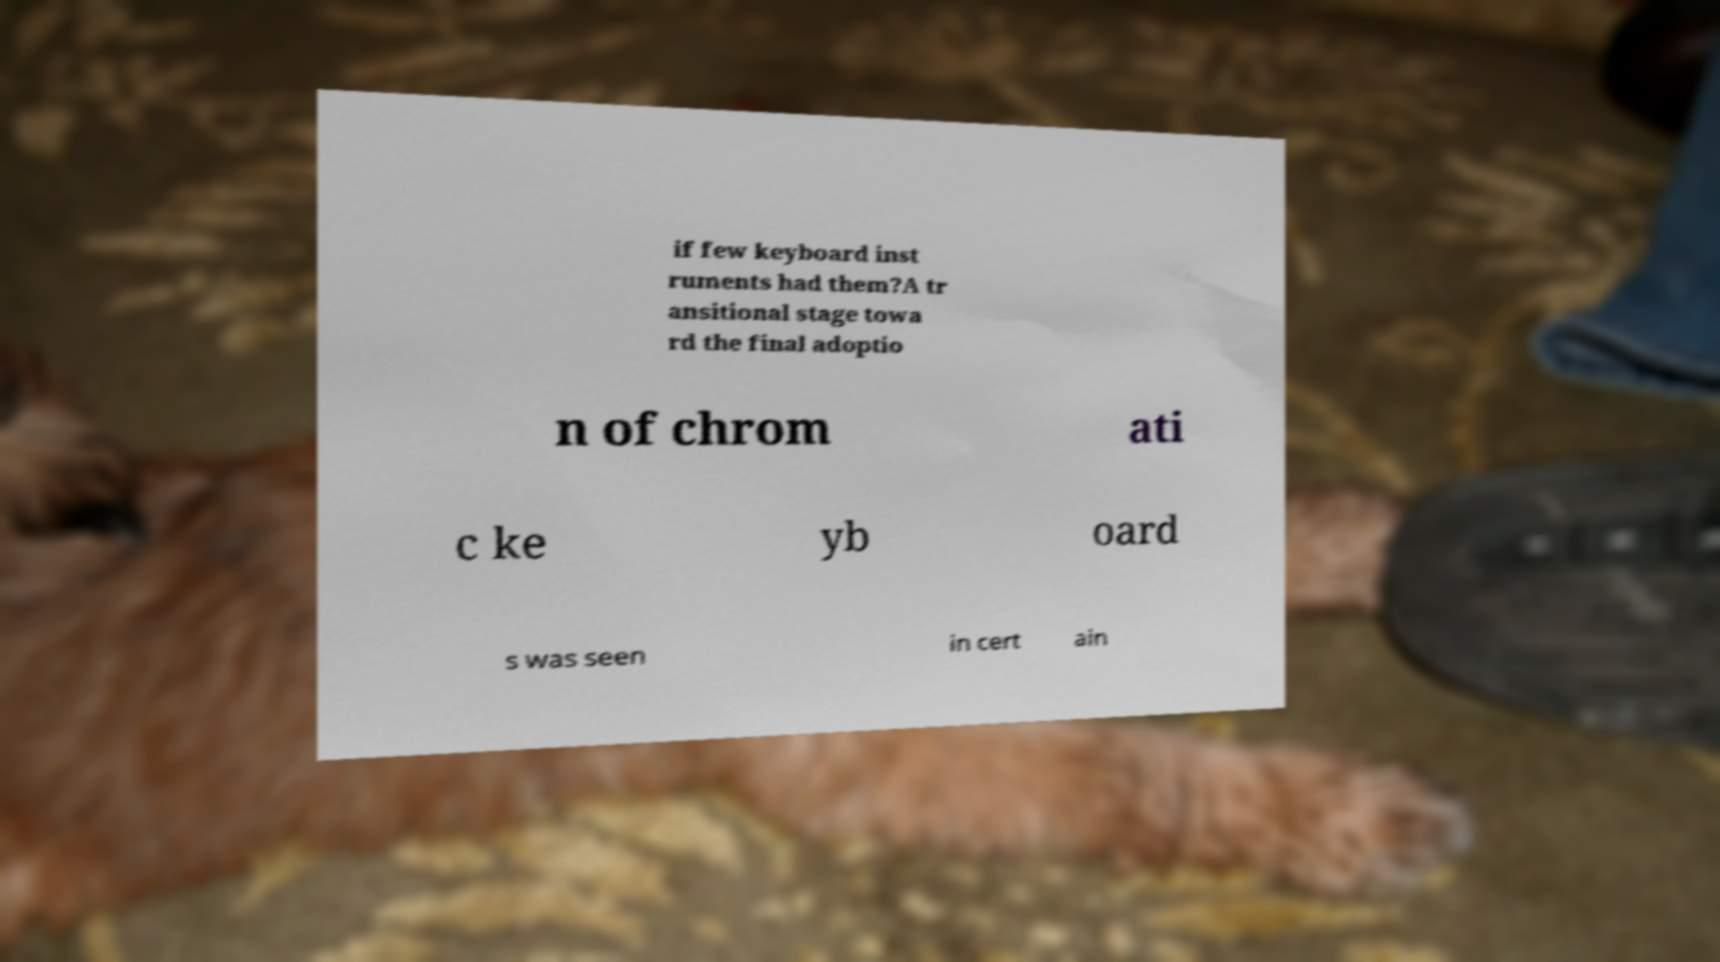For documentation purposes, I need the text within this image transcribed. Could you provide that? if few keyboard inst ruments had them?A tr ansitional stage towa rd the final adoptio n of chrom ati c ke yb oard s was seen in cert ain 